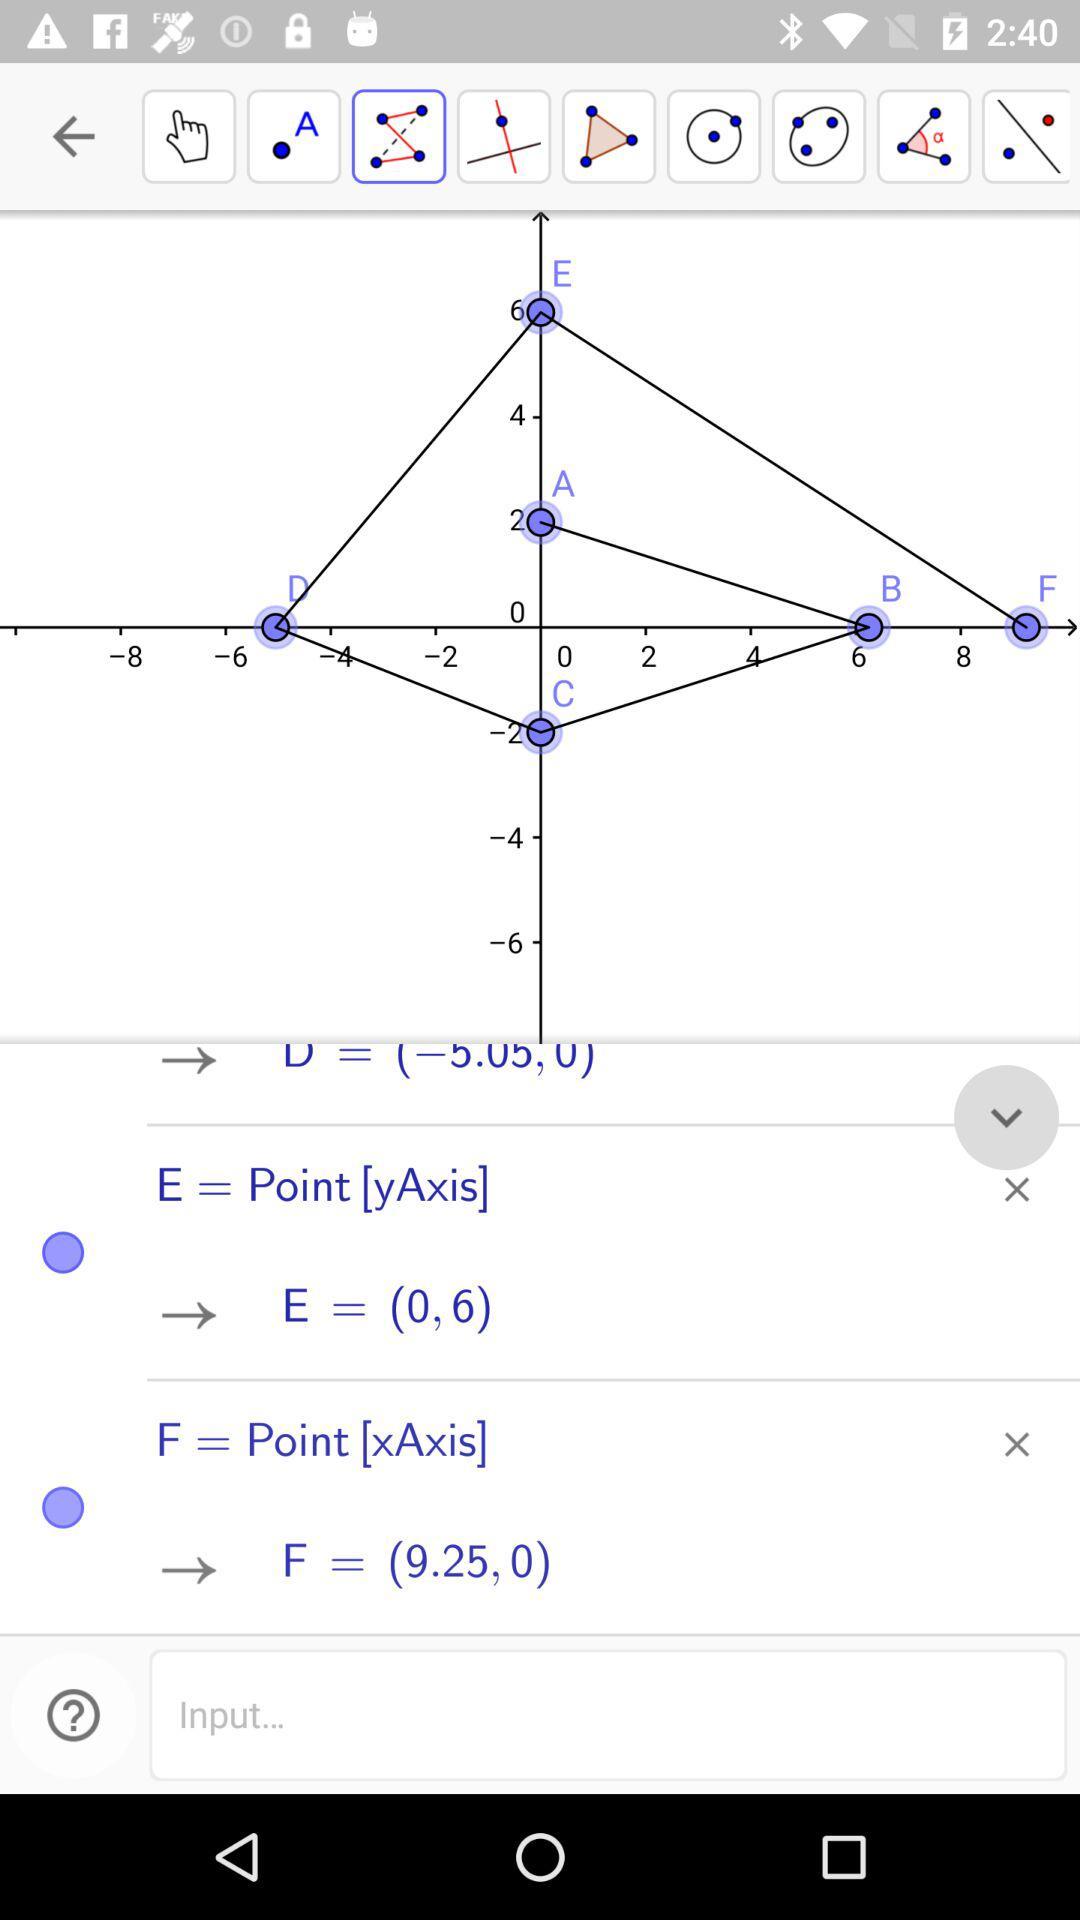The A point is on which axis?
When the provided information is insufficient, respond with <no answer>. <no answer> 